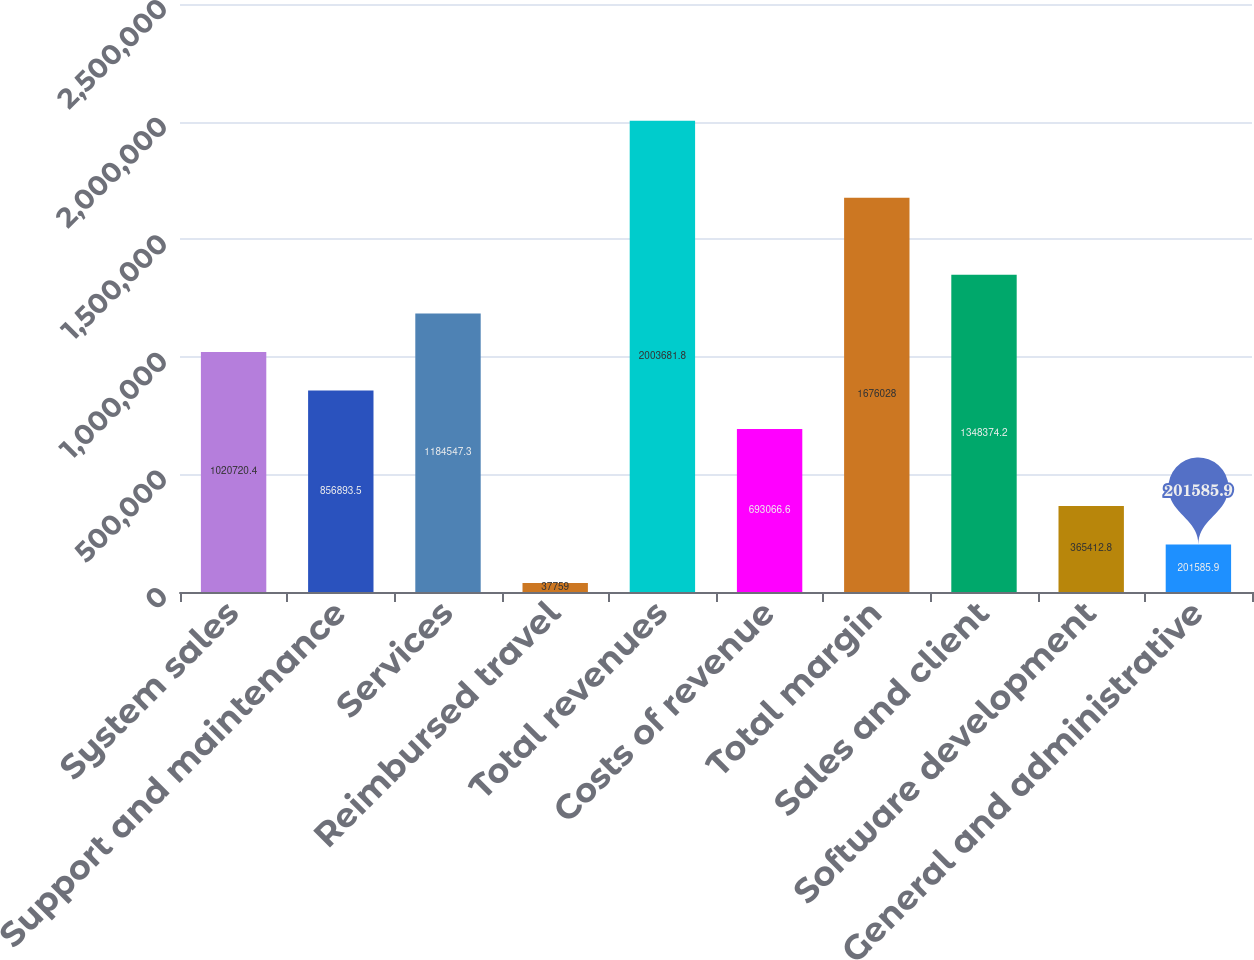<chart> <loc_0><loc_0><loc_500><loc_500><bar_chart><fcel>System sales<fcel>Support and maintenance<fcel>Services<fcel>Reimbursed travel<fcel>Total revenues<fcel>Costs of revenue<fcel>Total margin<fcel>Sales and client<fcel>Software development<fcel>General and administrative<nl><fcel>1.02072e+06<fcel>856894<fcel>1.18455e+06<fcel>37759<fcel>2.00368e+06<fcel>693067<fcel>1.67603e+06<fcel>1.34837e+06<fcel>365413<fcel>201586<nl></chart> 